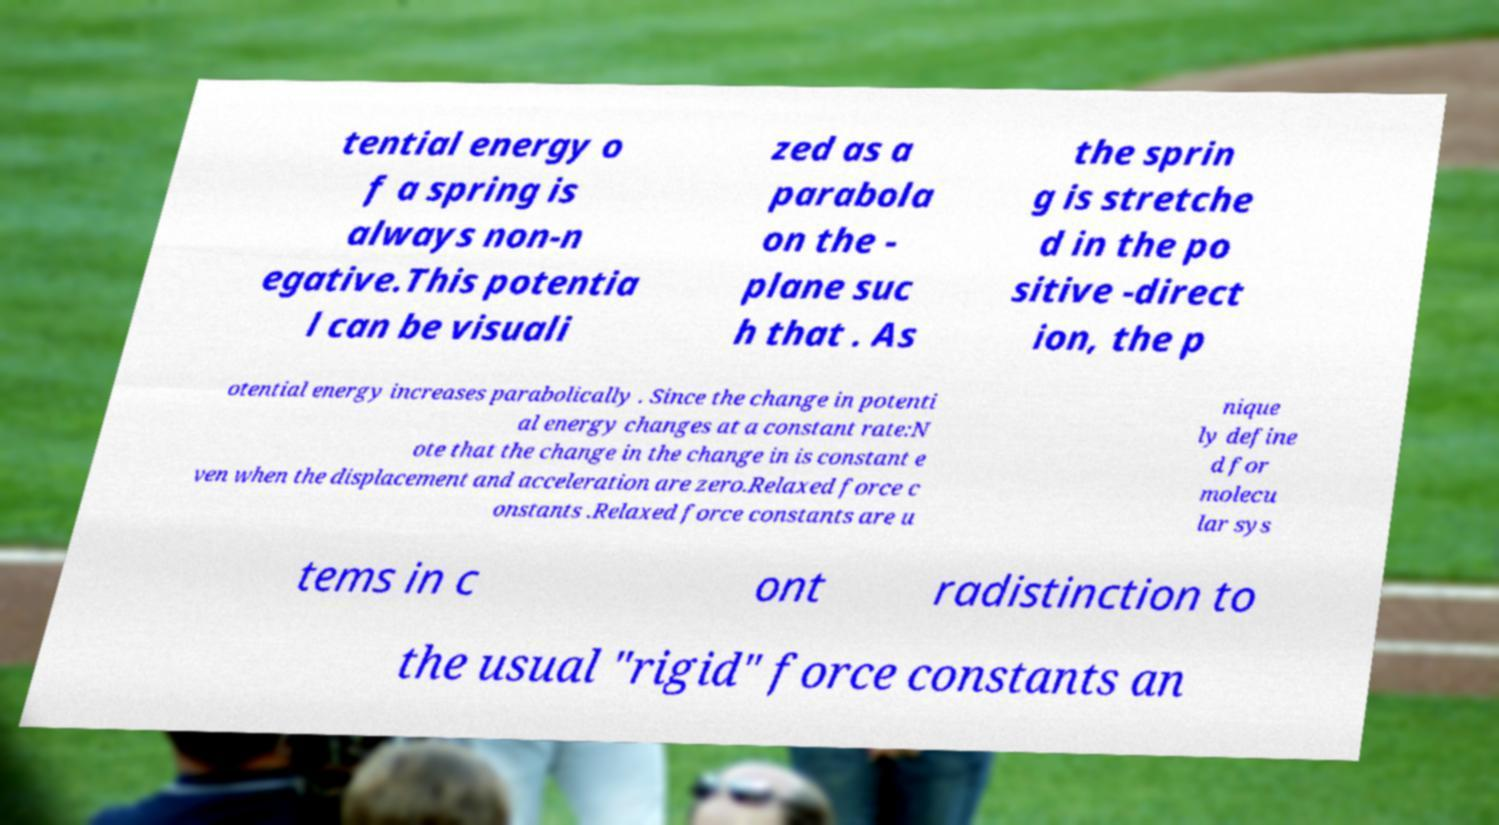Can you accurately transcribe the text from the provided image for me? tential energy o f a spring is always non-n egative.This potentia l can be visuali zed as a parabola on the - plane suc h that . As the sprin g is stretche d in the po sitive -direct ion, the p otential energy increases parabolically . Since the change in potenti al energy changes at a constant rate:N ote that the change in the change in is constant e ven when the displacement and acceleration are zero.Relaxed force c onstants .Relaxed force constants are u nique ly define d for molecu lar sys tems in c ont radistinction to the usual "rigid" force constants an 